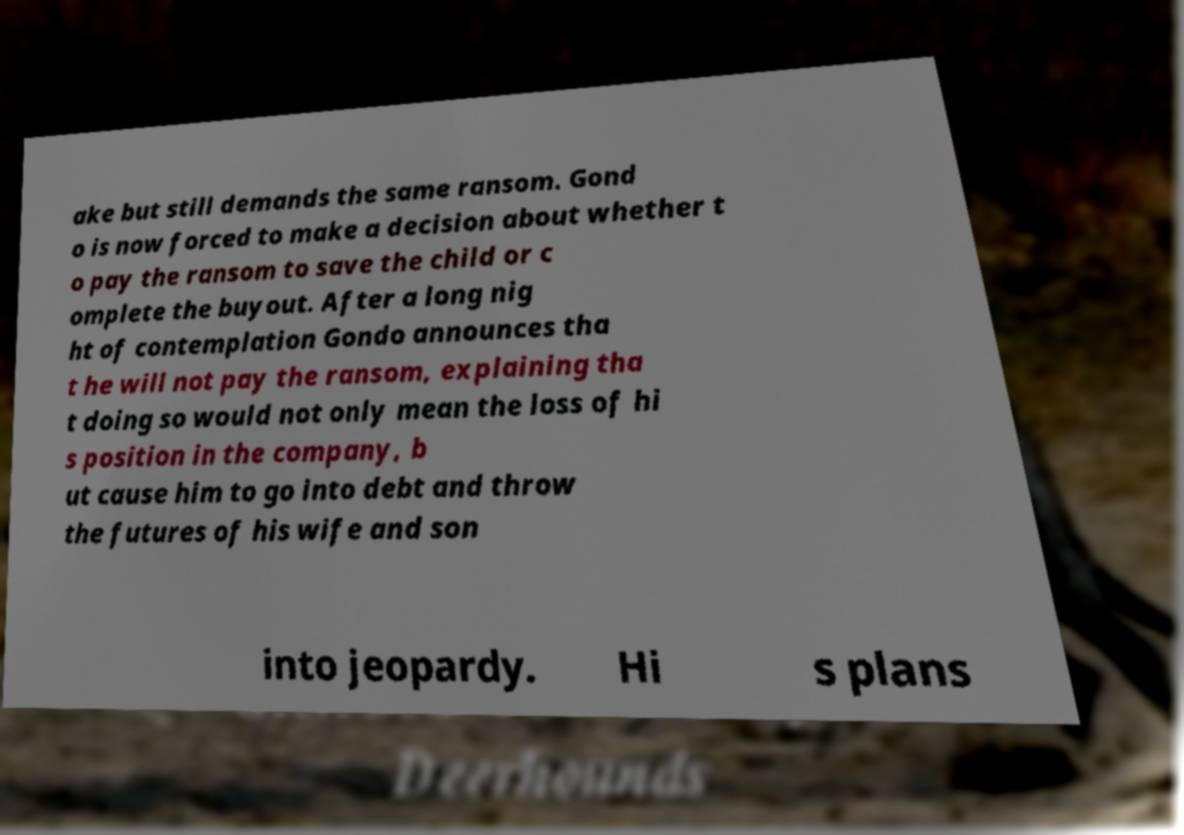Could you extract and type out the text from this image? ake but still demands the same ransom. Gond o is now forced to make a decision about whether t o pay the ransom to save the child or c omplete the buyout. After a long nig ht of contemplation Gondo announces tha t he will not pay the ransom, explaining tha t doing so would not only mean the loss of hi s position in the company, b ut cause him to go into debt and throw the futures of his wife and son into jeopardy. Hi s plans 